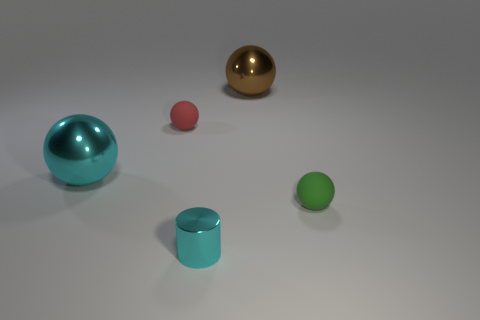How many balls are either brown objects or tiny green things?
Offer a terse response. 2. There is a cyan metal object behind the tiny green rubber thing; are there any large brown things in front of it?
Offer a terse response. No. Is there any other thing that is made of the same material as the brown ball?
Your answer should be compact. Yes. Is the shape of the tiny metal thing the same as the object that is right of the brown sphere?
Your answer should be compact. No. What number of other objects are the same size as the brown object?
Offer a very short reply. 1. How many blue objects are either metal cylinders or tiny matte spheres?
Ensure brevity in your answer.  0. What number of shiny objects are right of the big cyan sphere and behind the small green sphere?
Offer a terse response. 1. There is a big ball in front of the shiny thing behind the red rubber sphere in front of the big brown shiny sphere; what is its material?
Ensure brevity in your answer.  Metal. How many red spheres have the same material as the cyan ball?
Your answer should be compact. 0. What is the shape of the thing that is the same color as the tiny cylinder?
Offer a very short reply. Sphere. 